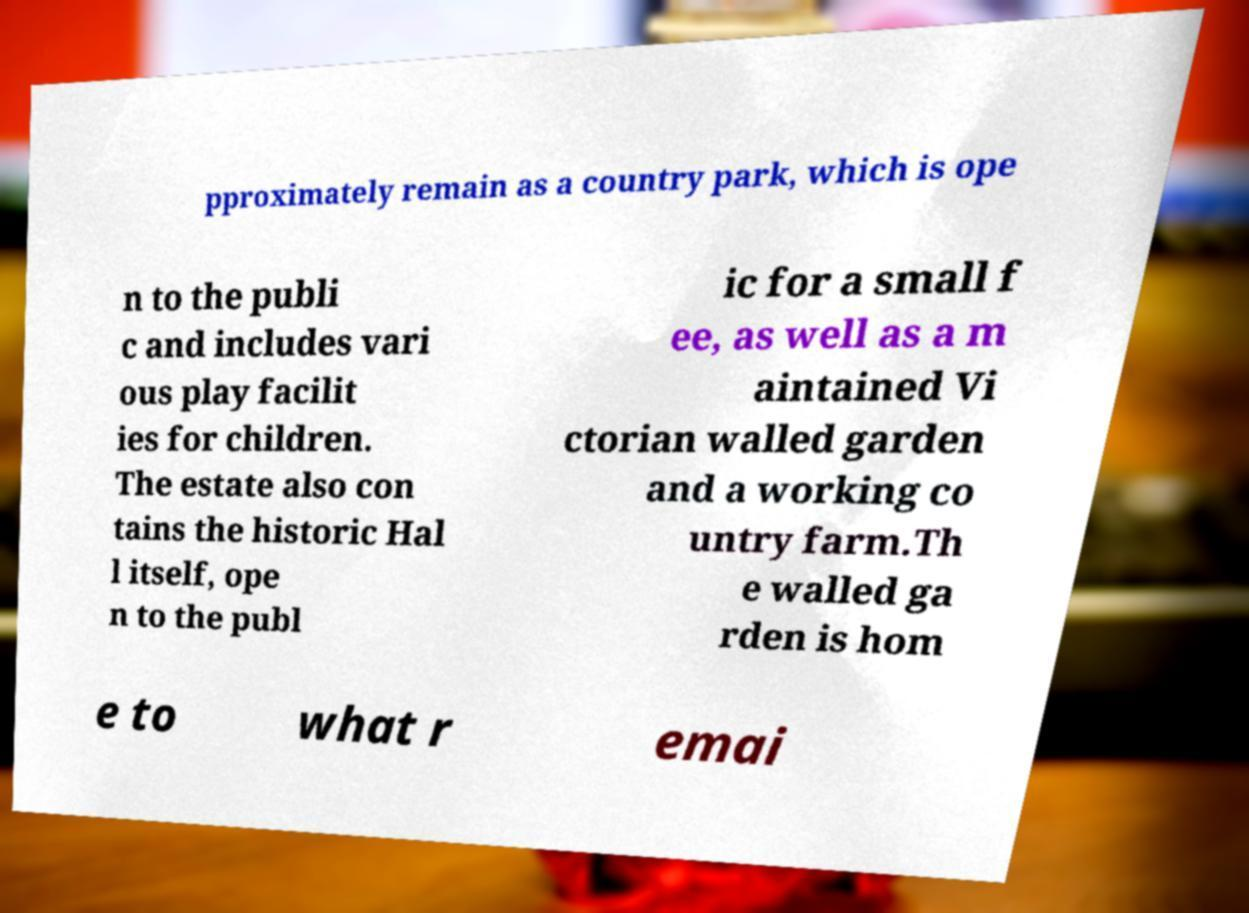Please identify and transcribe the text found in this image. pproximately remain as a country park, which is ope n to the publi c and includes vari ous play facilit ies for children. The estate also con tains the historic Hal l itself, ope n to the publ ic for a small f ee, as well as a m aintained Vi ctorian walled garden and a working co untry farm.Th e walled ga rden is hom e to what r emai 